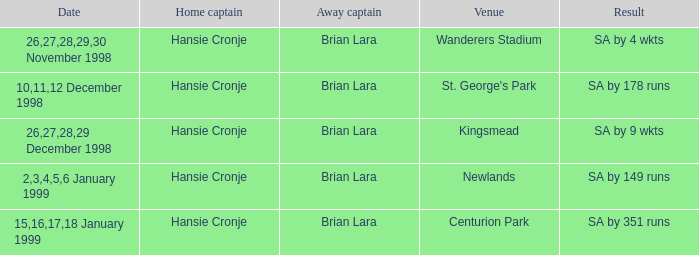Who serves as the away captain in kingsmead? Brian Lara. 